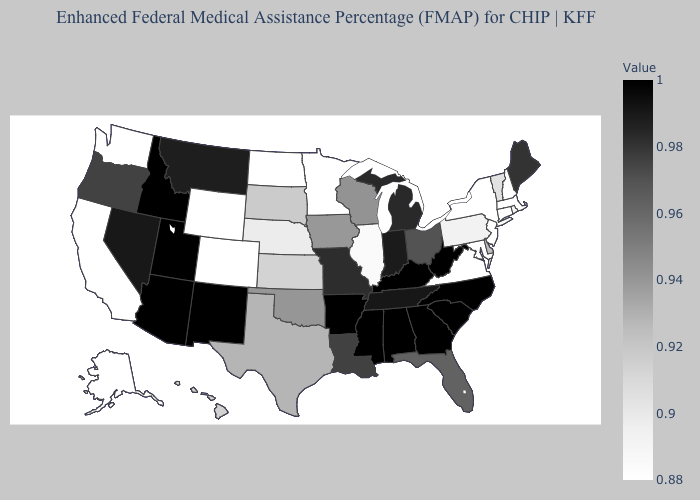Does New Jersey have the lowest value in the USA?
Concise answer only. Yes. Which states have the highest value in the USA?
Write a very short answer. Alabama, Arizona, Arkansas, Georgia, Idaho, Kentucky, Mississippi, New Mexico, North Carolina, South Carolina, Utah, West Virginia. Does Vermont have a higher value than New York?
Concise answer only. Yes. Does the map have missing data?
Be succinct. No. Among the states that border Virginia , which have the lowest value?
Quick response, please. Maryland. Among the states that border Mississippi , does Alabama have the highest value?
Write a very short answer. Yes. Among the states that border New Jersey , does Delaware have the highest value?
Give a very brief answer. Yes. Which states have the lowest value in the South?
Give a very brief answer. Maryland, Virginia. Does Indiana have the highest value in the MidWest?
Be succinct. Yes. 